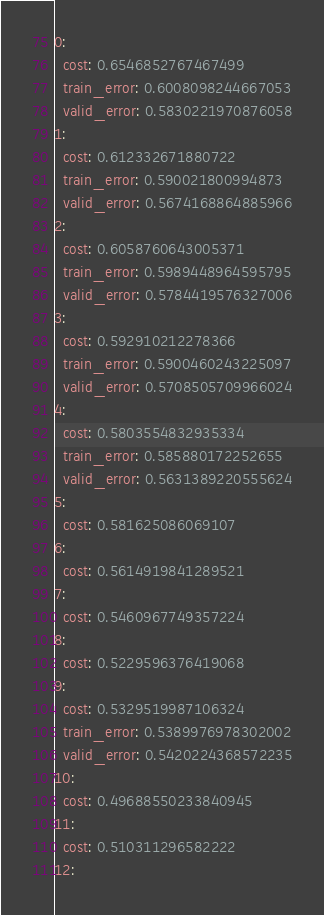Convert code to text. <code><loc_0><loc_0><loc_500><loc_500><_YAML_>0:
  cost: 0.6546852767467499
  train_error: 0.6008098244667053
  valid_error: 0.5830221970876058
1:
  cost: 0.612332671880722
  train_error: 0.590021800994873
  valid_error: 0.5674168864885966
2:
  cost: 0.6058760643005371
  train_error: 0.5989448964595795
  valid_error: 0.5784419576327006
3:
  cost: 0.592910212278366
  train_error: 0.5900460243225097
  valid_error: 0.5708505709966024
4:
  cost: 0.5803554832935334
  train_error: 0.585880172252655
  valid_error: 0.5631389220555624
5:
  cost: 0.581625086069107
6:
  cost: 0.5614919841289521
7:
  cost: 0.5460967749357224
8:
  cost: 0.5229596376419068
9:
  cost: 0.5329519987106324
  train_error: 0.5389976978302002
  valid_error: 0.5420224368572235
10:
  cost: 0.49688550233840945
11:
  cost: 0.510311296582222
12:</code> 